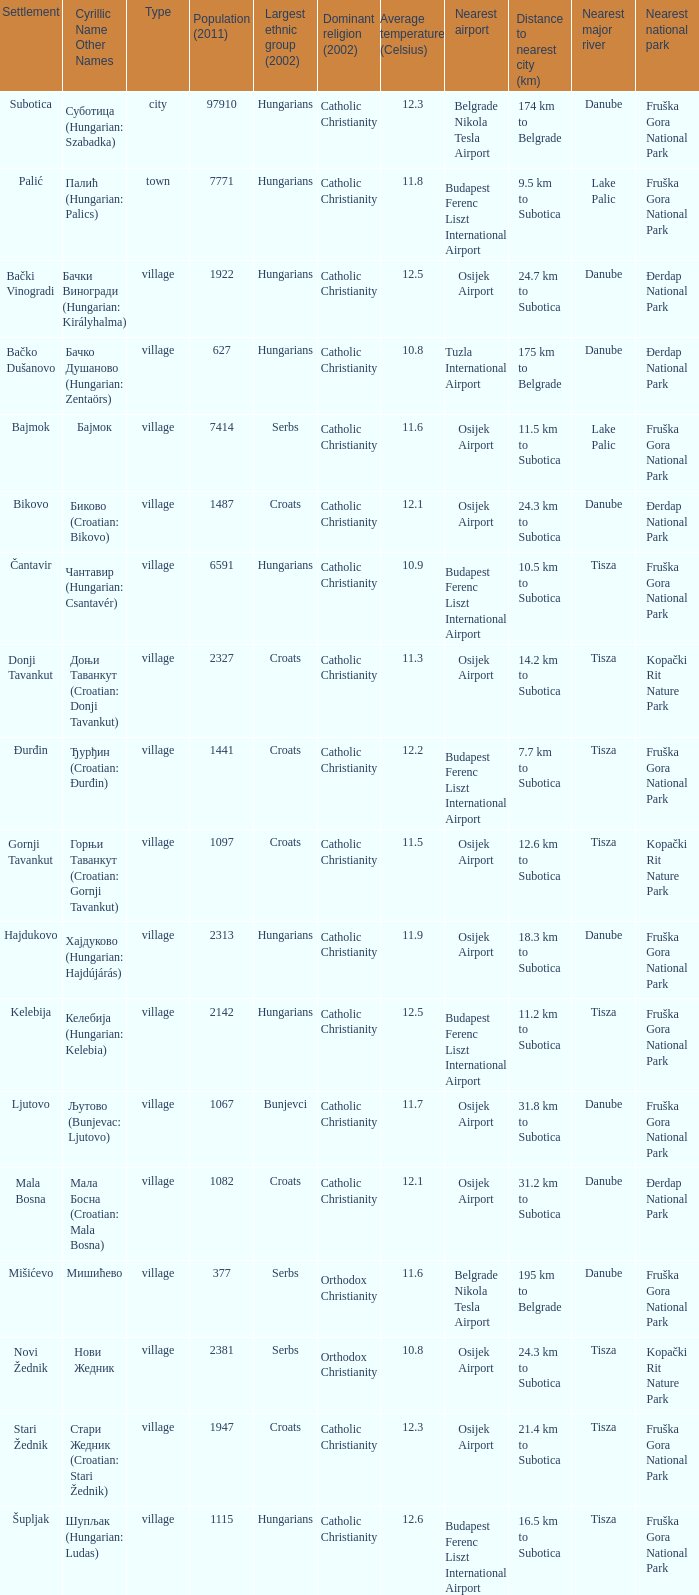What type of settlement has a population of 1441? Village. 